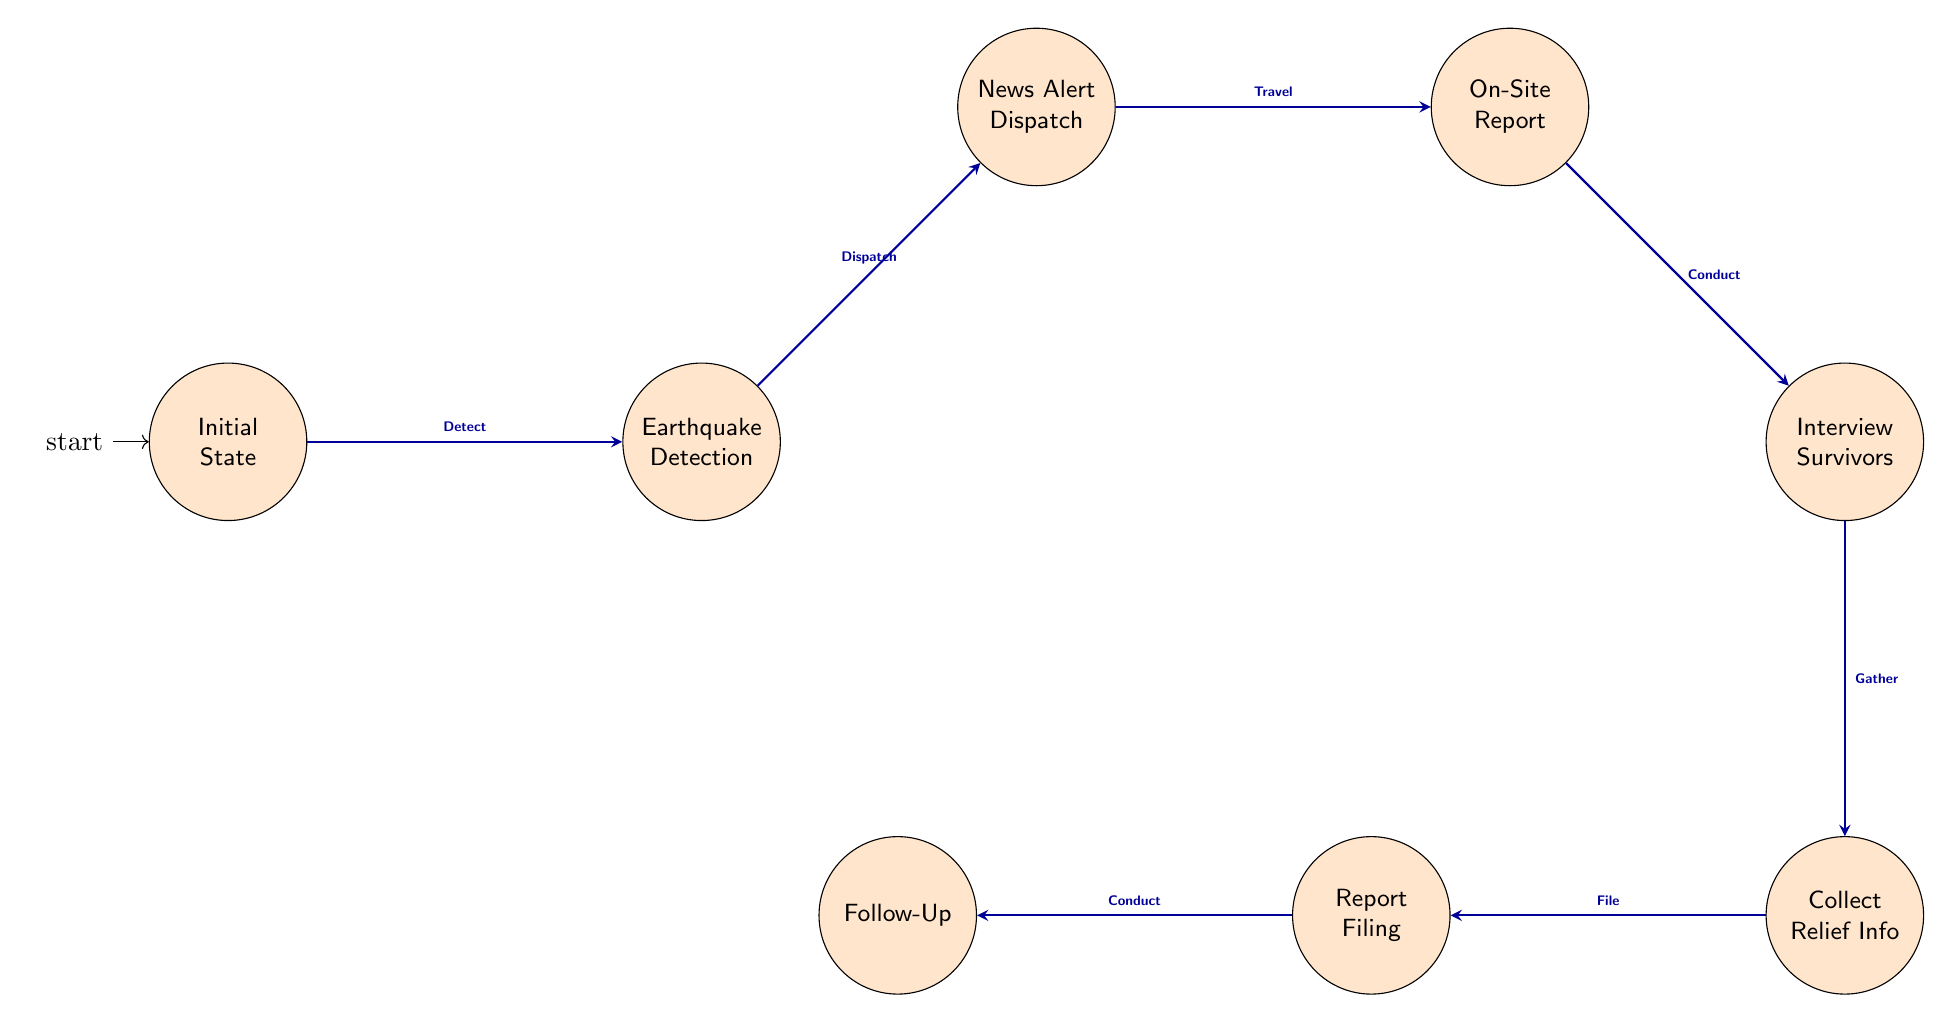What is the starting point of the workflow? The initial state is indicated as the starting point in the diagram where no action has been taken yet.
Answer: Initial state How many nodes are in the workflow? Counting the nodes in the diagram, we find there are a total of eight different states present in the workflow.
Answer: Eight What action triggers the transition from "Initial state" to "Earthquake detection"? The diagram shows that the action that triggers this transition is "Detect Earthquake".
Answer: Detect Earthquake Which state comes after "Collect Relief Info"? The flow indicates that after "Collect Relief Info", the next state is "Report Filing".
Answer: Report Filing What must be done after traveling to the site? After reaching the "On-Site Report" state, the next action that must be completed is "Conduct Interviews".
Answer: Conduct Interviews What action follows after "Interview Survivors"? Based on the flow from "Interview Survivors", the next action to undertake is "Gather Relief Efforts Information".
Answer: Gather Relief Efforts Information How does one move from "Report Filing" to "Follow-Up"? The transition from "Report Filing" to "Follow-Up" occurs through the action of "Conduct Follow-up Reporting".
Answer: Conduct Follow-up Reporting Why is "News Alert Dispatch" significant in the process? It represents a crucial step as it notifies the public about the detected earthquake, serving as the first point of communication following detection.
Answer: It notifies the public What action connects "Earthquake Detection" to "News Alert Dispatch"? The action required to make this connection is "Dispatch News Alert".
Answer: Dispatch News Alert 